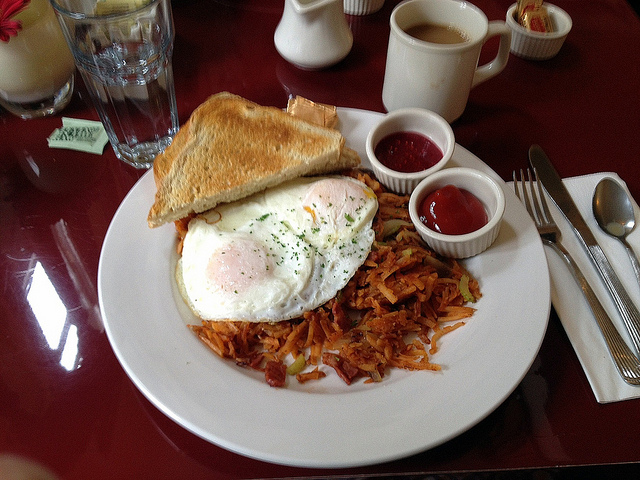What is the state of the meal? The meal on the plate is freshly prepared and served hot, ready to be enjoyed. The eggs are done just right, suggesting they are likely freshly cooked, and the toast looks warm and crispy, perfect for a satisfying breakfast. 